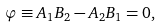Convert formula to latex. <formula><loc_0><loc_0><loc_500><loc_500>\varphi \equiv A _ { 1 } B _ { 2 } - A _ { 2 } B _ { 1 } = 0 ,</formula> 